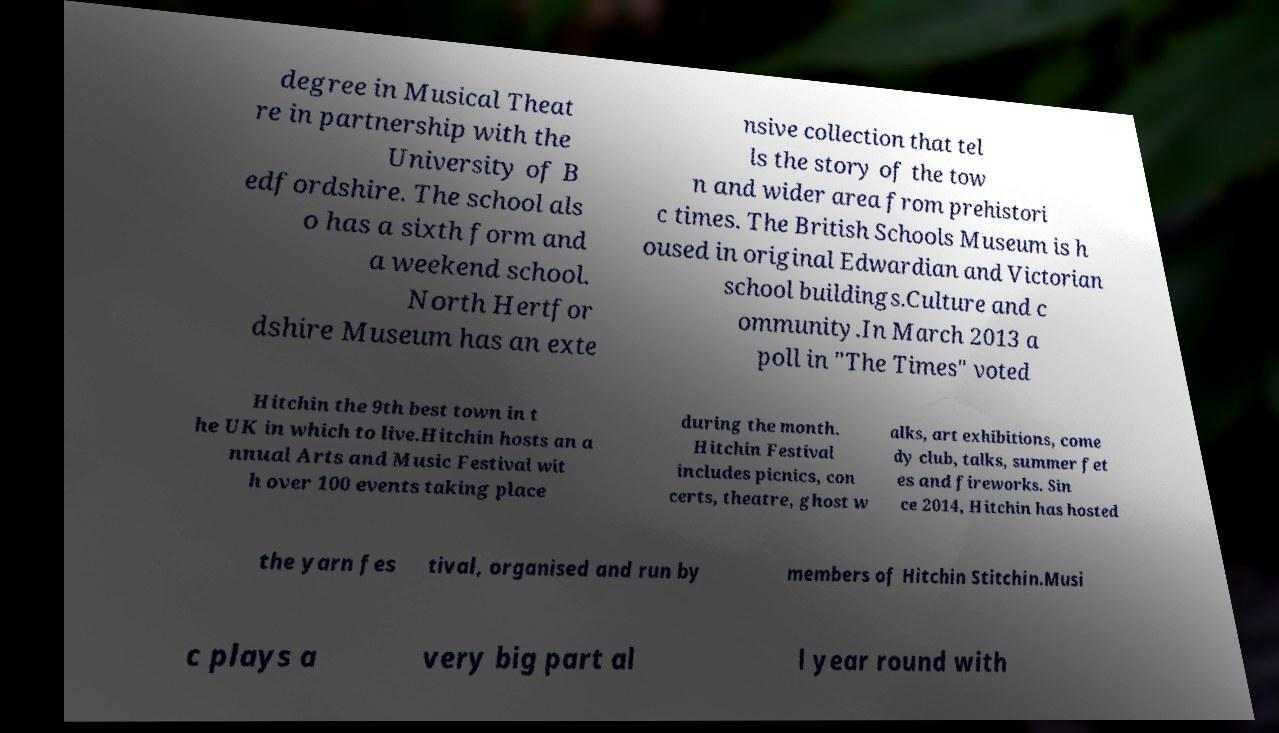For documentation purposes, I need the text within this image transcribed. Could you provide that? degree in Musical Theat re in partnership with the University of B edfordshire. The school als o has a sixth form and a weekend school. North Hertfor dshire Museum has an exte nsive collection that tel ls the story of the tow n and wider area from prehistori c times. The British Schools Museum is h oused in original Edwardian and Victorian school buildings.Culture and c ommunity.In March 2013 a poll in "The Times" voted Hitchin the 9th best town in t he UK in which to live.Hitchin hosts an a nnual Arts and Music Festival wit h over 100 events taking place during the month. Hitchin Festival includes picnics, con certs, theatre, ghost w alks, art exhibitions, come dy club, talks, summer fet es and fireworks. Sin ce 2014, Hitchin has hosted the yarn fes tival, organised and run by members of Hitchin Stitchin.Musi c plays a very big part al l year round with 